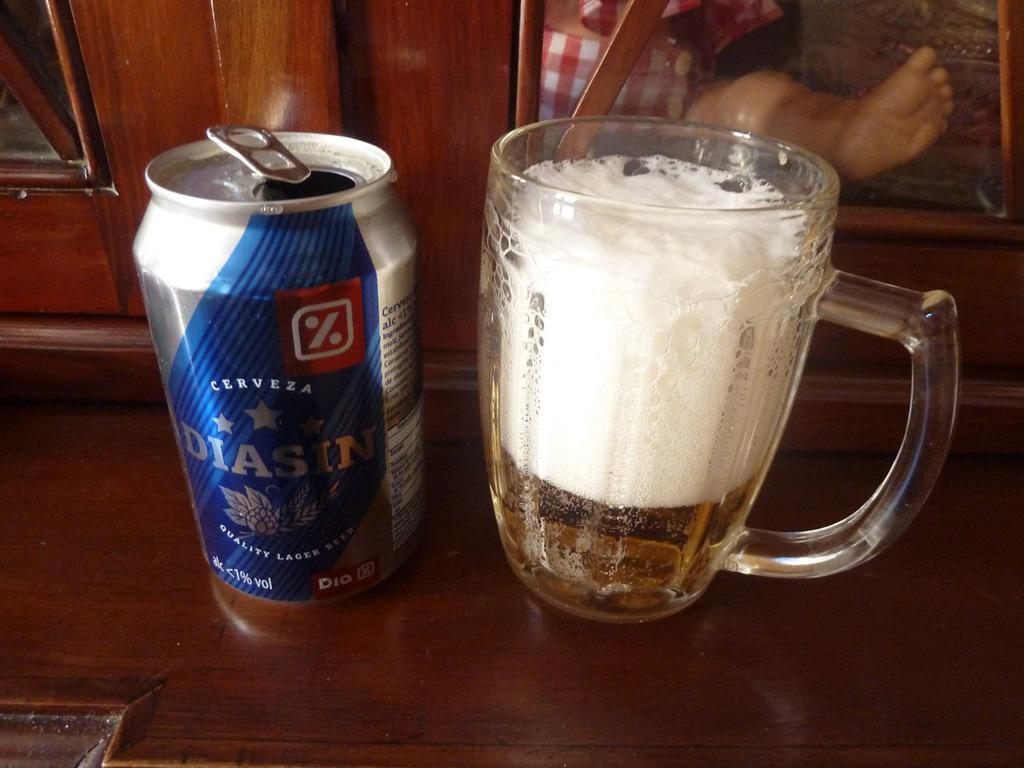Could you give a brief overview of what you see in this image? In the center of the image we can see one table. On the table, we can see one can and one glass. In the background there is a door, human leg and a few other objects. 